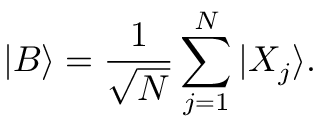<formula> <loc_0><loc_0><loc_500><loc_500>| B \rangle = \frac { 1 } { \sqrt { N } } \sum _ { j = 1 } ^ { N } | X _ { j } \rangle .</formula> 